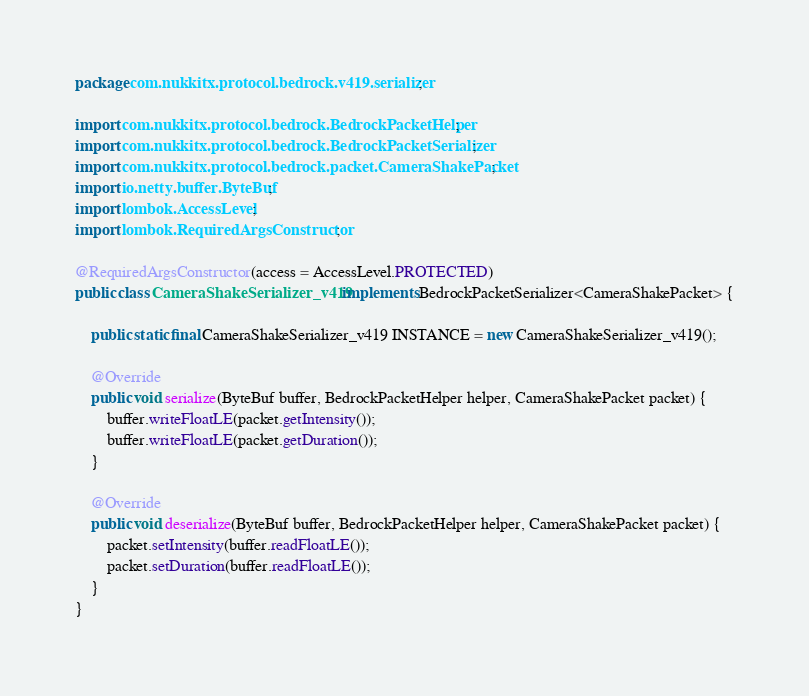<code> <loc_0><loc_0><loc_500><loc_500><_Java_>package com.nukkitx.protocol.bedrock.v419.serializer;

import com.nukkitx.protocol.bedrock.BedrockPacketHelper;
import com.nukkitx.protocol.bedrock.BedrockPacketSerializer;
import com.nukkitx.protocol.bedrock.packet.CameraShakePacket;
import io.netty.buffer.ByteBuf;
import lombok.AccessLevel;
import lombok.RequiredArgsConstructor;

@RequiredArgsConstructor(access = AccessLevel.PROTECTED)
public class CameraShakeSerializer_v419 implements BedrockPacketSerializer<CameraShakePacket> {

    public static final CameraShakeSerializer_v419 INSTANCE = new CameraShakeSerializer_v419();

    @Override
    public void serialize(ByteBuf buffer, BedrockPacketHelper helper, CameraShakePacket packet) {
        buffer.writeFloatLE(packet.getIntensity());
        buffer.writeFloatLE(packet.getDuration());
    }

    @Override
    public void deserialize(ByteBuf buffer, BedrockPacketHelper helper, CameraShakePacket packet) {
        packet.setIntensity(buffer.readFloatLE());
        packet.setDuration(buffer.readFloatLE());
    }
}
</code> 